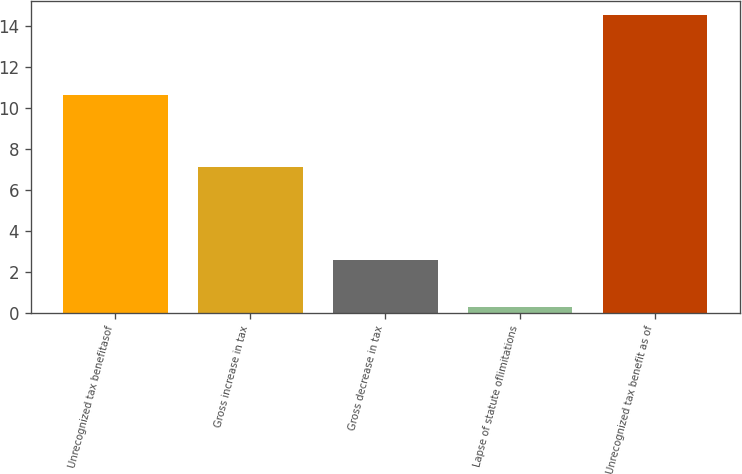Convert chart. <chart><loc_0><loc_0><loc_500><loc_500><bar_chart><fcel>Unrecognized tax benefitasof<fcel>Gross increase in tax<fcel>Gross decrease in tax<fcel>Lapse of statute oflimitations<fcel>Unrecognized tax benefit as of<nl><fcel>10.6<fcel>7.1<fcel>2.6<fcel>0.3<fcel>14.5<nl></chart> 